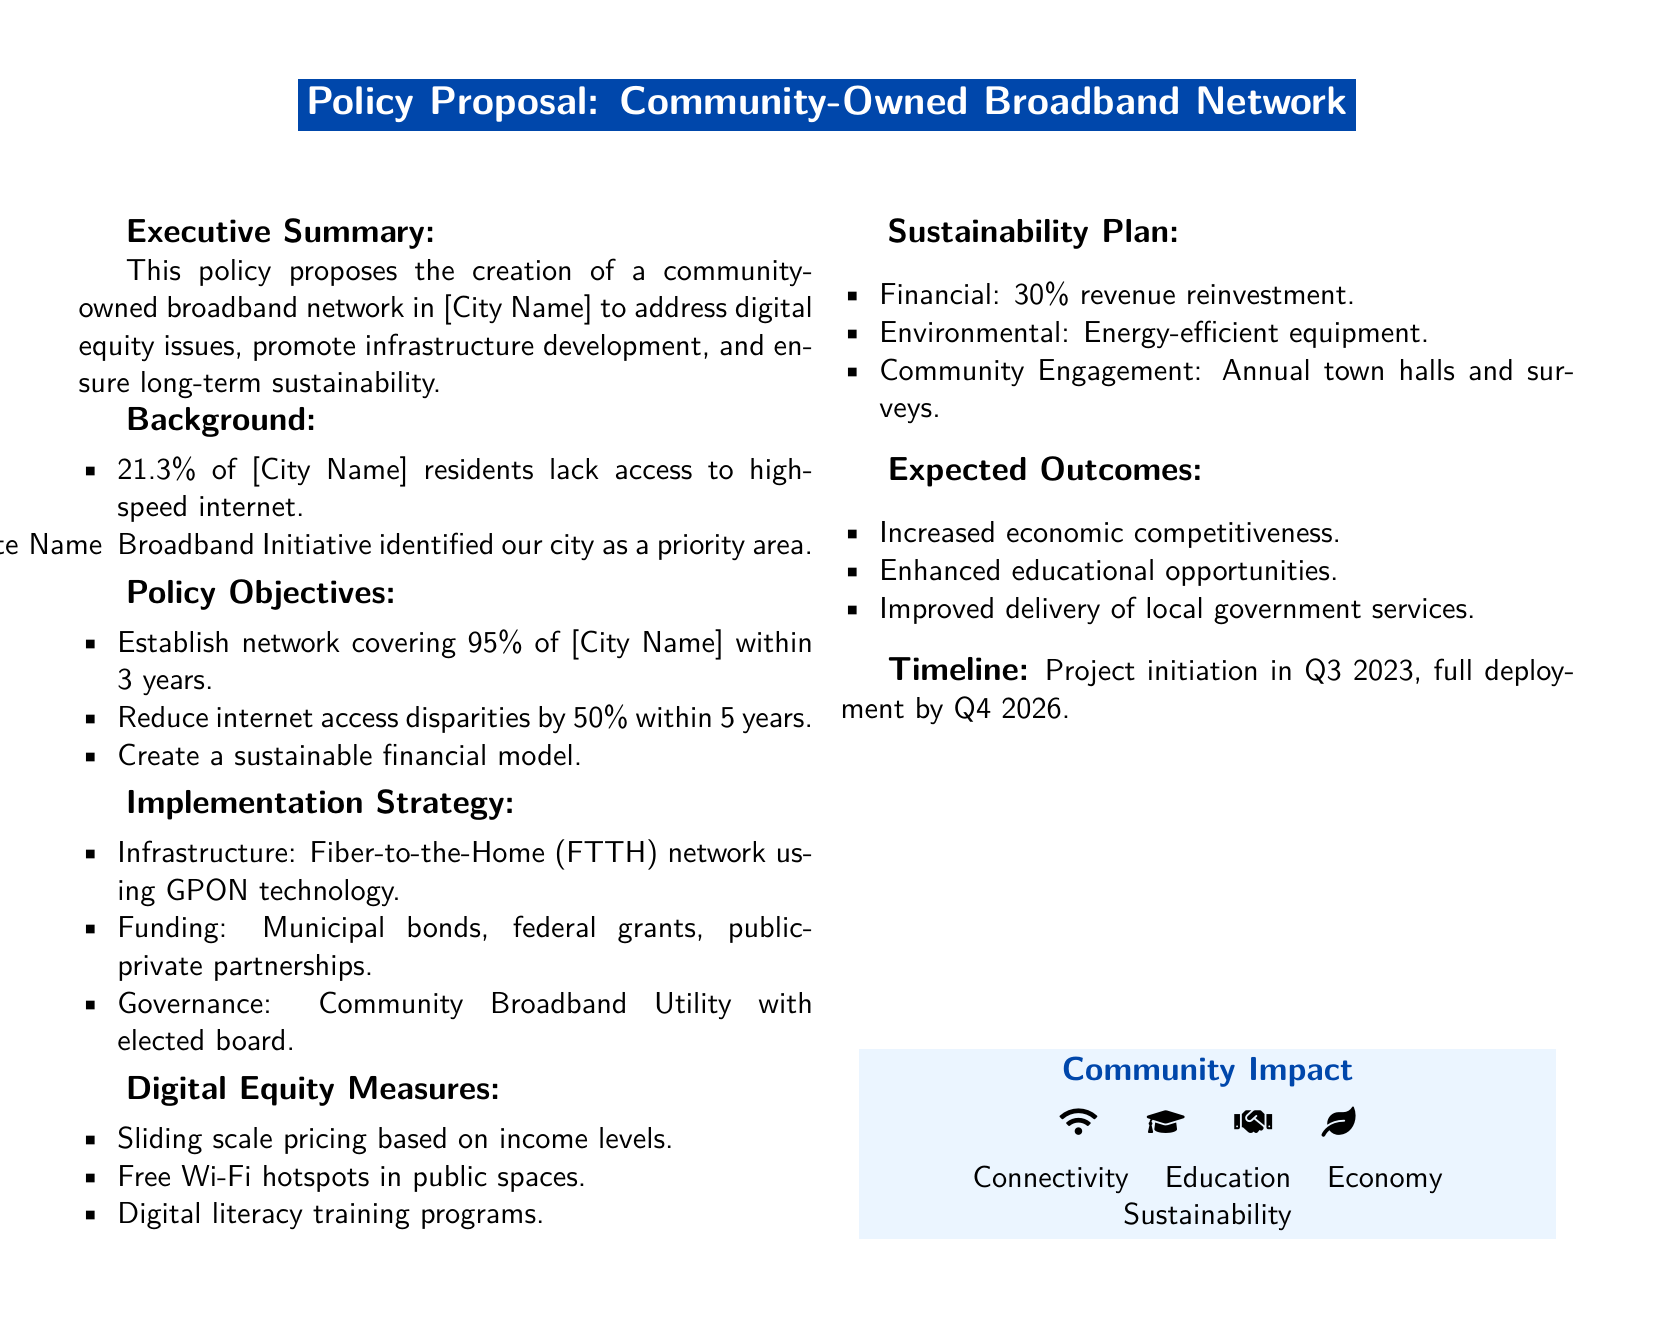What percentage of residents lack access to high-speed internet? The document states that 21.3% of residents lack access to high-speed internet.
Answer: 21.3% What is the objective regarding internet access disparities? The objective is to reduce internet access disparities by 50% within 5 years.
Answer: 50% What year is the full deployment of the network expected? The timeline indicates that full deployment is expected by Q4 2026.
Answer: Q4 2026 What technology will be used for the infrastructure? The infrastructure will use Fiber-to-the-Home (FTTH) network using GPON technology.
Answer: GPON technology What is the funding source mentioned for the project? The funding sources include municipal bonds, federal grants, and public-private partnerships.
Answer: Municipal bonds, federal grants, public-private partnerships What is one of the digital equity measures proposed? The document lists sliding scale pricing based on income levels as a measure for digital equity.
Answer: Sliding scale pricing How much of the revenue will be reinvested according to the sustainability plan? The document specifies 30% revenue reinvestment in the sustainability plan.
Answer: 30% What is a community engagement plan mentioned in the document? The document mentions annual town halls and surveys as part of community engagement.
Answer: Annual town halls and surveys What are the expected outcomes related to educational opportunities? The document states that one expected outcome is enhanced educational opportunities.
Answer: Enhanced educational opportunities 